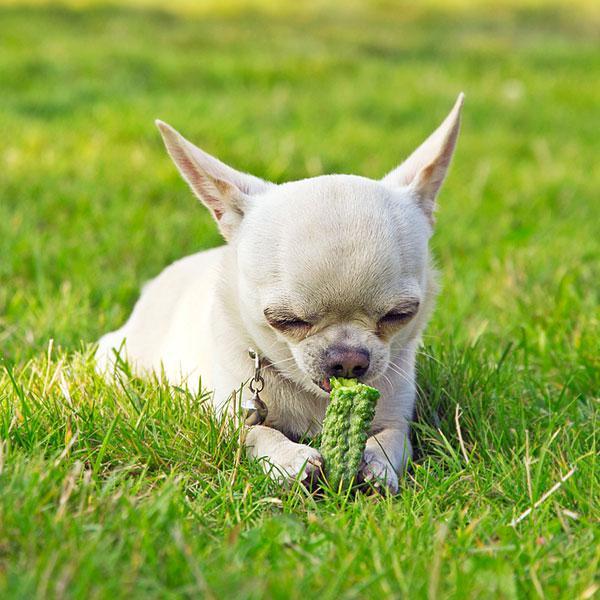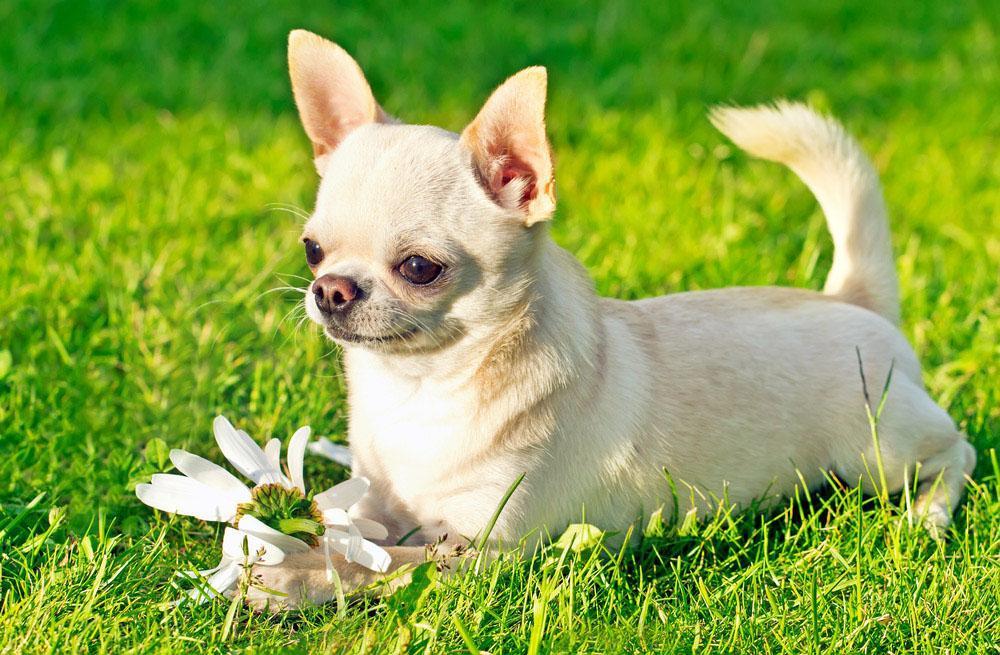The first image is the image on the left, the second image is the image on the right. Examine the images to the left and right. Is the description "The dog in the image on the left is lying on the grass." accurate? Answer yes or no. Yes. The first image is the image on the left, the second image is the image on the right. Evaluate the accuracy of this statement regarding the images: "All chihuahuas are shown posed on green grass, and one chihuahua has its head pointed downward toward something green.". Is it true? Answer yes or no. Yes. 